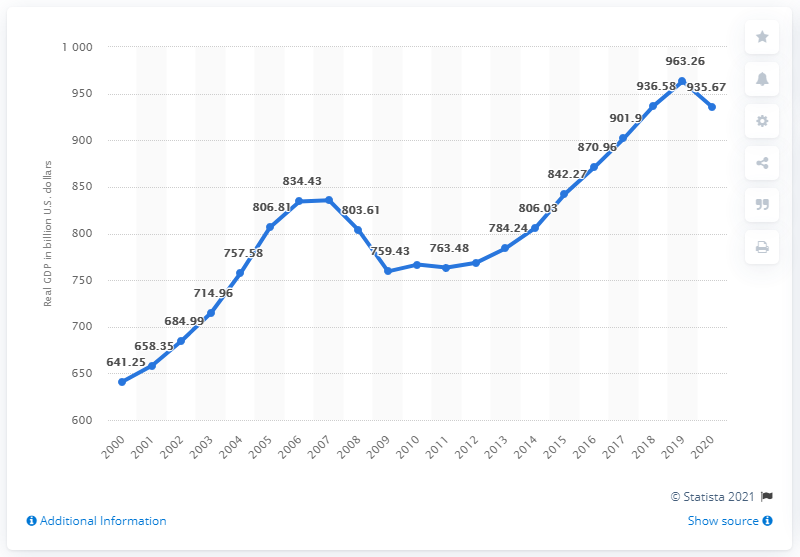Point out several critical features in this image. In 2020, the Gross Domestic Product (GDP) of Florida was 935.67 billion dollars. The previous year's GDP of Florida was 963.26... 